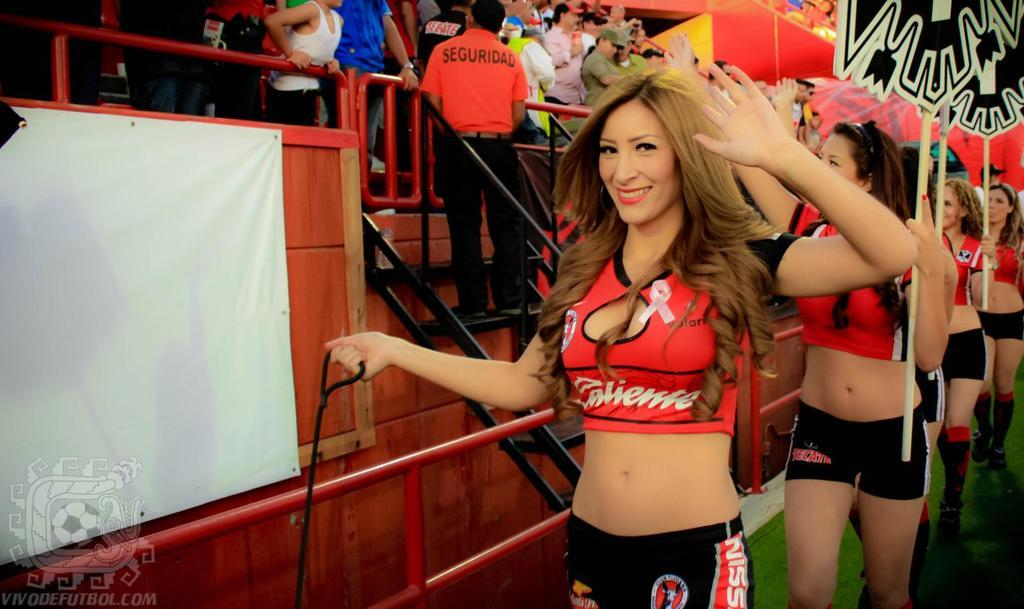What are the people in the image doing? The people in the image are walking and holding sticks. Where are some of the people located in the image? Some people are standing on the left side of the image. What architectural feature can be seen in the image? There are stairs visible in the image. Can you see any cobwebs in the image? There is no mention of cobwebs in the provided facts, so we cannot determine if any are present in the image. 